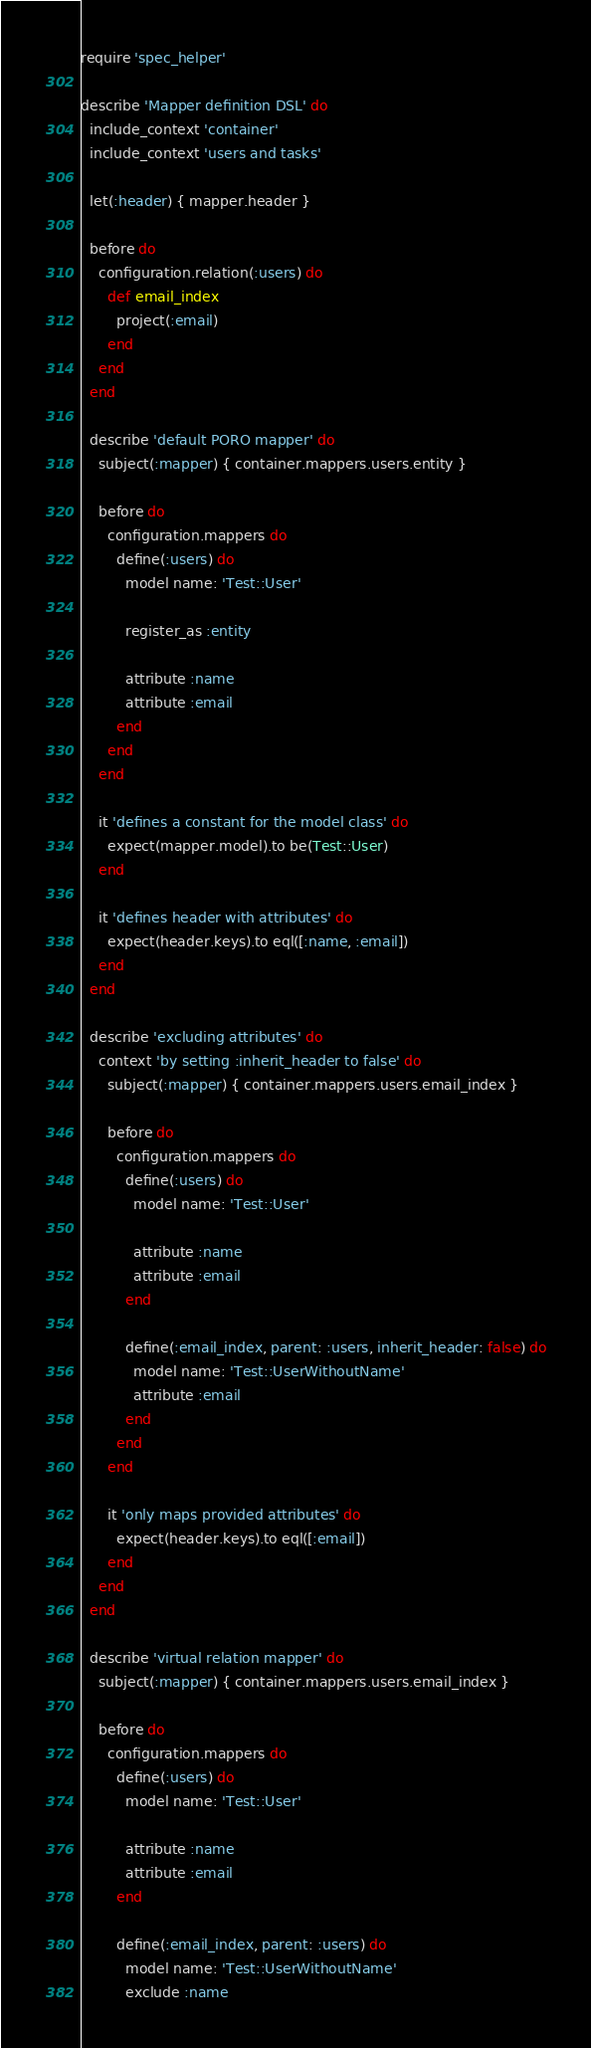Convert code to text. <code><loc_0><loc_0><loc_500><loc_500><_Ruby_>require 'spec_helper'

describe 'Mapper definition DSL' do
  include_context 'container'
  include_context 'users and tasks'

  let(:header) { mapper.header }

  before do
    configuration.relation(:users) do
      def email_index
        project(:email)
      end
    end
  end

  describe 'default PORO mapper' do
    subject(:mapper) { container.mappers.users.entity }

    before do
      configuration.mappers do
        define(:users) do
          model name: 'Test::User'

          register_as :entity

          attribute :name
          attribute :email
        end
      end
    end

    it 'defines a constant for the model class' do
      expect(mapper.model).to be(Test::User)
    end

    it 'defines header with attributes' do
      expect(header.keys).to eql([:name, :email])
    end
  end

  describe 'excluding attributes' do
    context 'by setting :inherit_header to false' do
      subject(:mapper) { container.mappers.users.email_index }

      before do
        configuration.mappers do
          define(:users) do
            model name: 'Test::User'

            attribute :name
            attribute :email
          end

          define(:email_index, parent: :users, inherit_header: false) do
            model name: 'Test::UserWithoutName'
            attribute :email
          end
        end
      end

      it 'only maps provided attributes' do
        expect(header.keys).to eql([:email])
      end
    end
  end

  describe 'virtual relation mapper' do
    subject(:mapper) { container.mappers.users.email_index }

    before do
      configuration.mappers do
        define(:users) do
          model name: 'Test::User'

          attribute :name
          attribute :email
        end

        define(:email_index, parent: :users) do
          model name: 'Test::UserWithoutName'
          exclude :name</code> 